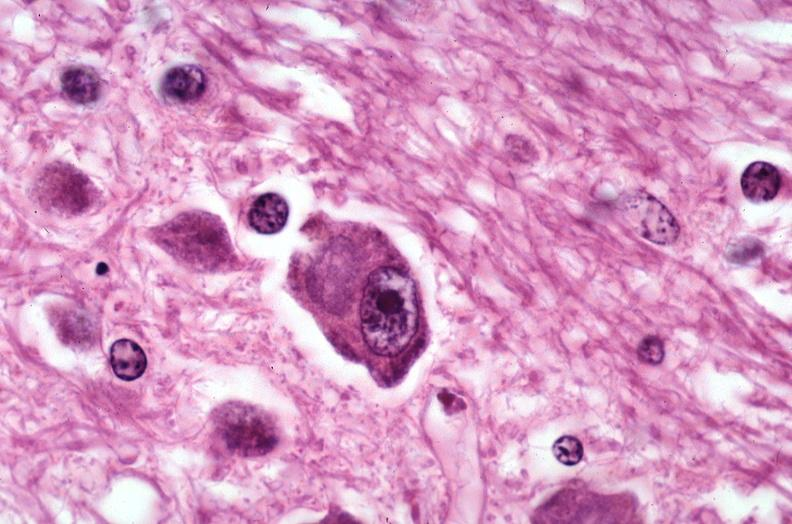what is present?
Answer the question using a single word or phrase. Nervous 